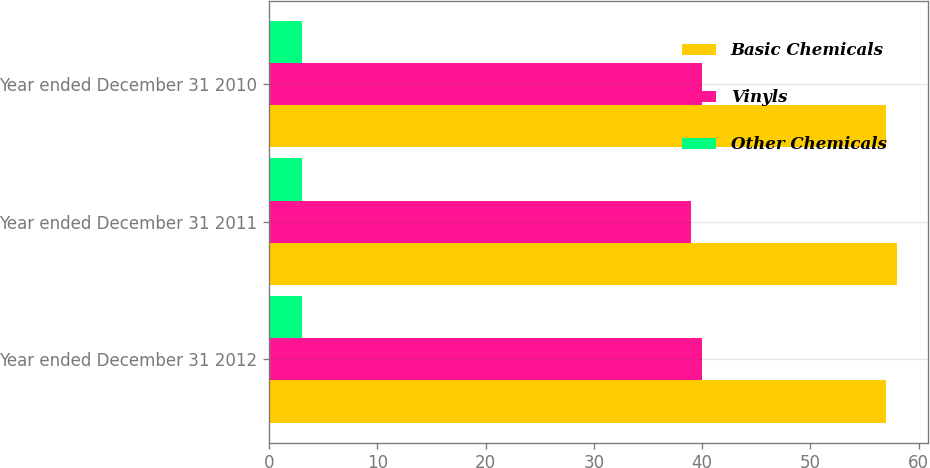<chart> <loc_0><loc_0><loc_500><loc_500><stacked_bar_chart><ecel><fcel>Year ended December 31 2012<fcel>Year ended December 31 2011<fcel>Year ended December 31 2010<nl><fcel>Basic Chemicals<fcel>57<fcel>58<fcel>57<nl><fcel>Vinyls<fcel>40<fcel>39<fcel>40<nl><fcel>Other Chemicals<fcel>3<fcel>3<fcel>3<nl></chart> 